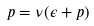Convert formula to latex. <formula><loc_0><loc_0><loc_500><loc_500>p = \nu ( \epsilon + p )</formula> 